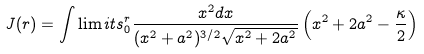<formula> <loc_0><loc_0><loc_500><loc_500>J ( r ) = \int \lim i t s _ { 0 } ^ { r } \frac { x ^ { 2 } d x } { ( x ^ { 2 } + a ^ { 2 } ) ^ { 3 / 2 } \sqrt { x ^ { 2 } + 2 a ^ { 2 } } } \left ( x ^ { 2 } + 2 a ^ { 2 } - \frac { \kappa } { 2 } \right )</formula> 